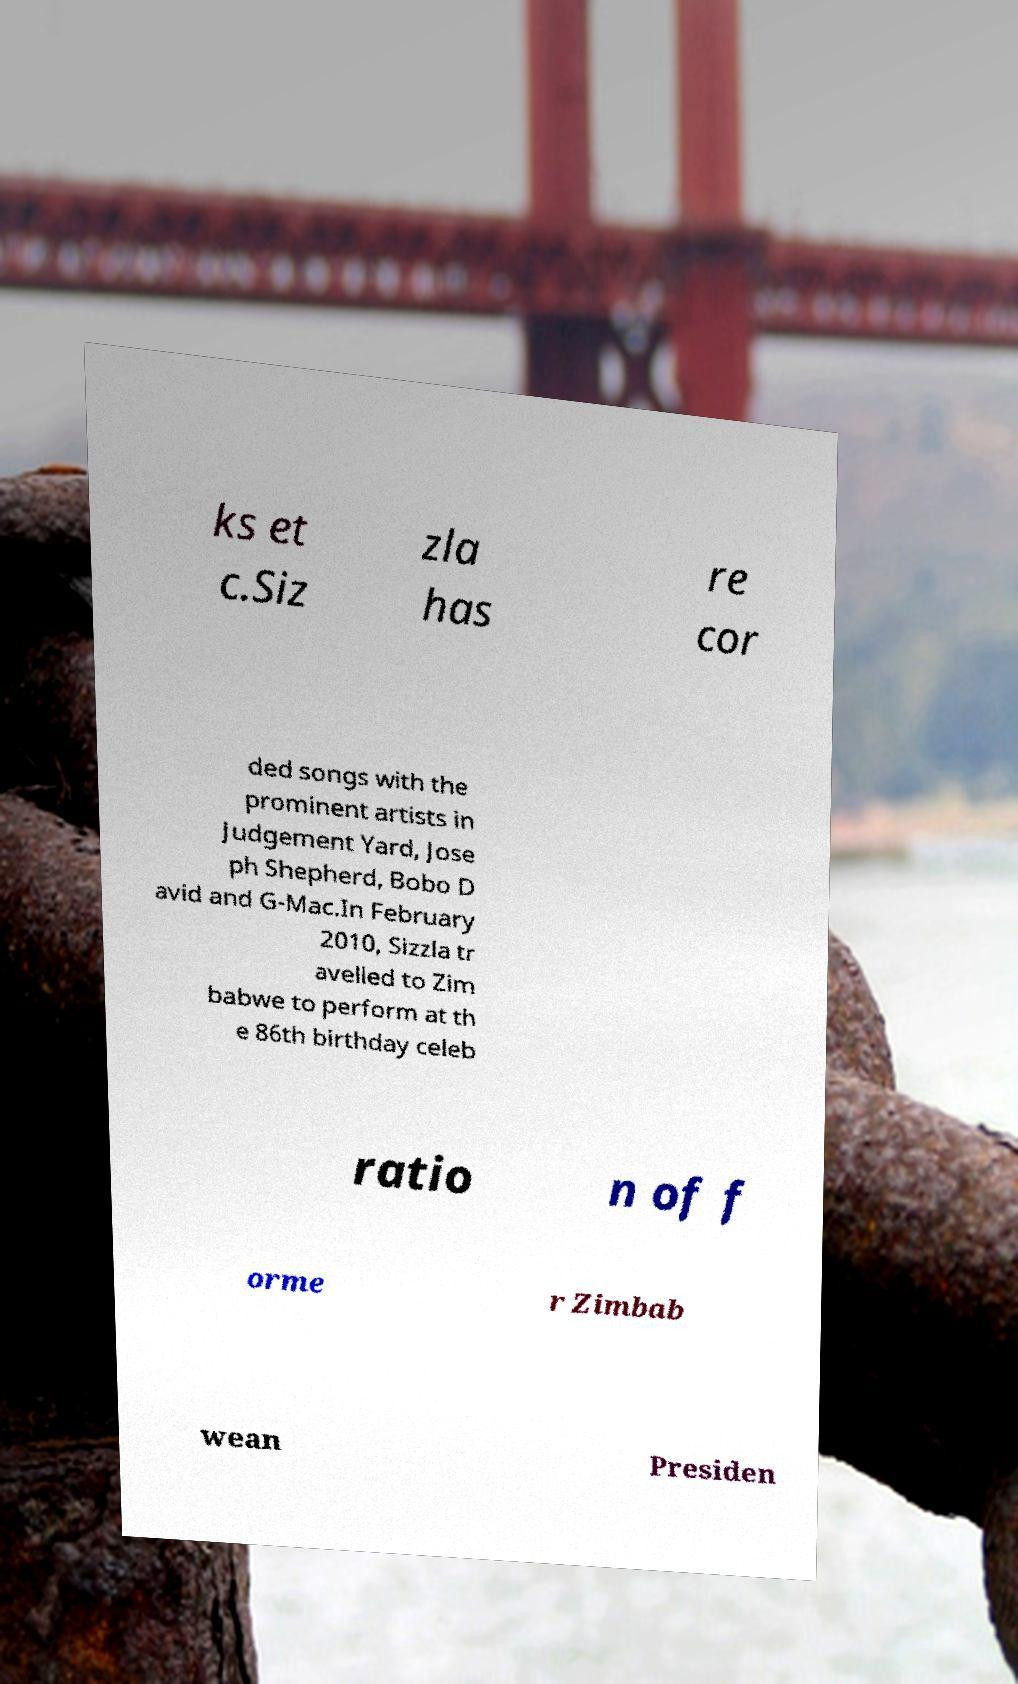Could you extract and type out the text from this image? ks et c.Siz zla has re cor ded songs with the prominent artists in Judgement Yard, Jose ph Shepherd, Bobo D avid and G-Mac.In February 2010, Sizzla tr avelled to Zim babwe to perform at th e 86th birthday celeb ratio n of f orme r Zimbab wean Presiden 